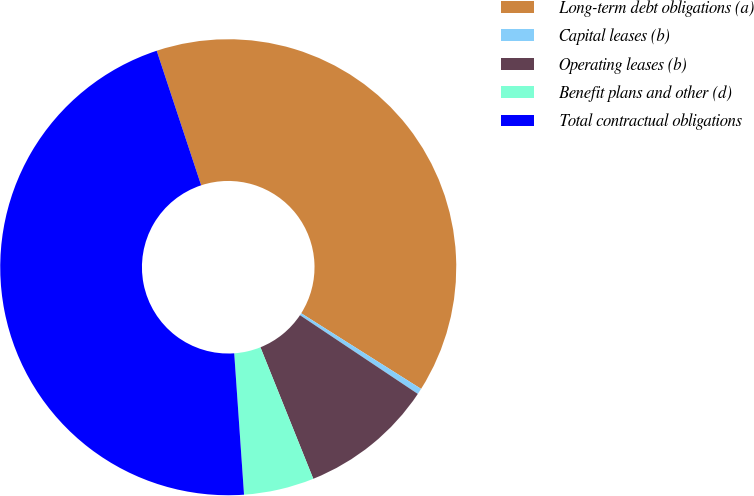Convert chart. <chart><loc_0><loc_0><loc_500><loc_500><pie_chart><fcel>Long-term debt obligations (a)<fcel>Capital leases (b)<fcel>Operating leases (b)<fcel>Benefit plans and other (d)<fcel>Total contractual obligations<nl><fcel>39.03%<fcel>0.42%<fcel>9.54%<fcel>4.98%<fcel>46.02%<nl></chart> 